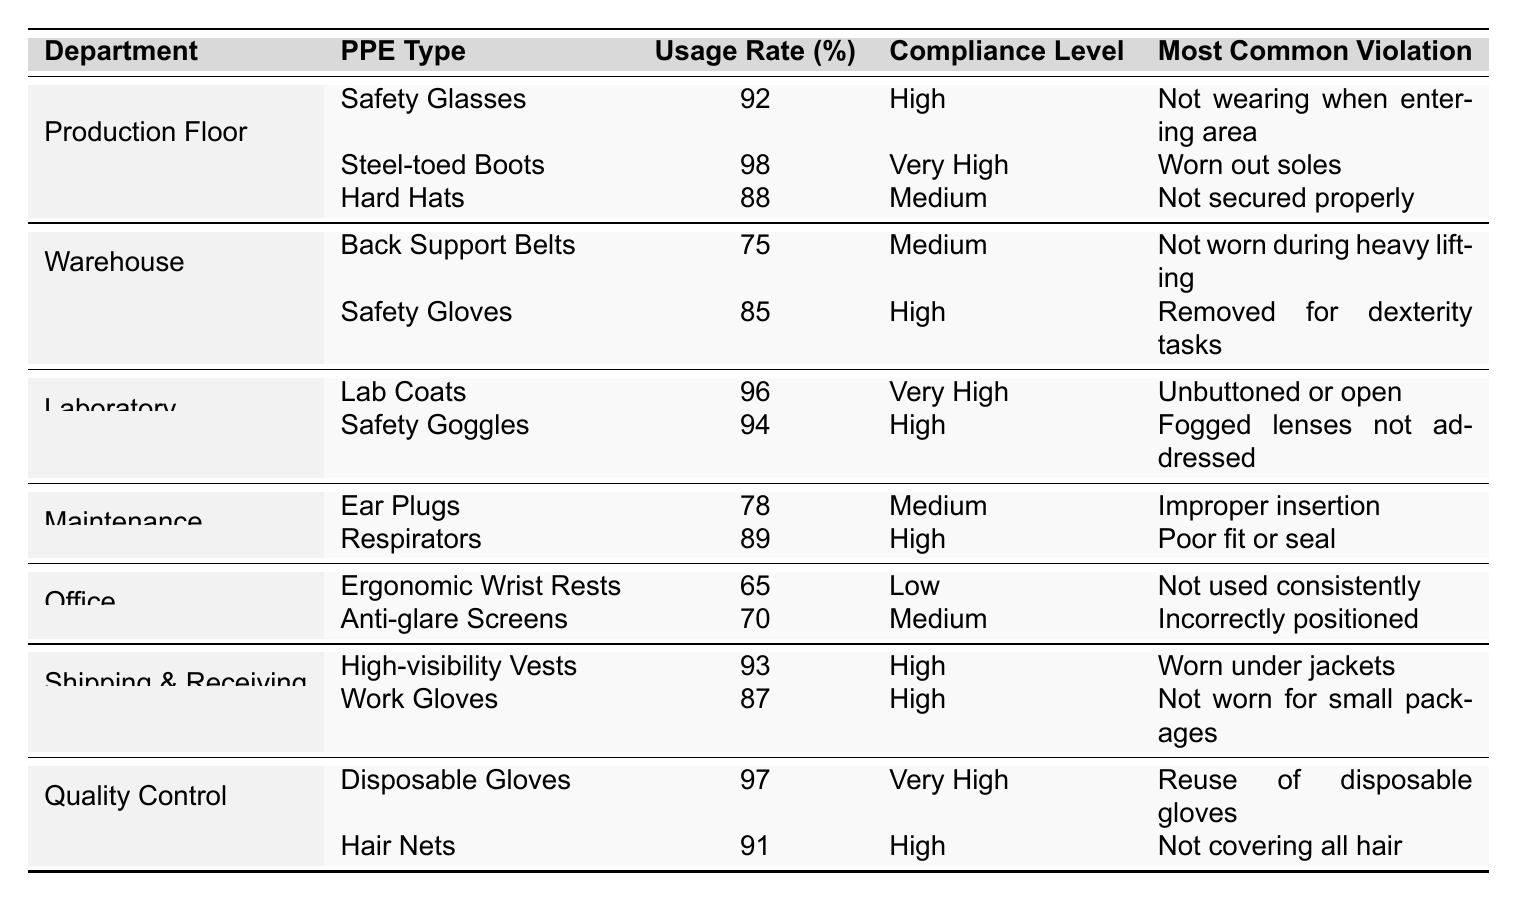What is the usage rate of safety glasses in the production floor? The table shows the usage rates for safety glasses in the production floor as 92%.
Answer: 92% Which department has the lowest PPE usage rate? Looking at the table, the office department has the lowest PPE usage rate of 65%.
Answer: 65% How many departments have a compliance level classified as "High"? The table lists the compliance levels, counting the "High" classifications, we find that there are 6 instances.
Answer: 6 What is the average usage rate of PPE in the warehouse? In the warehouse, the usage rates are 75% for back support belts and 85% for safety gloves. The average is (75 + 85) / 2 = 80%.
Answer: 80% Is the compliance level for ear plugs in maintenance classified as "Very High"? The table indicates that the compliance level for ear plugs in maintenance is "Medium", so it is not classified as "Very High".
Answer: No List the most common violation for safety goggles in the laboratory. The table states that the most common violation for safety goggles in the laboratory is "Fogged lenses not addressed".
Answer: Fogged lenses not addressed What is the difference in usage rates between steel-toed boots and work gloves? The usage rate for steel-toed boots in production is 98%, while for work gloves in shipping & receiving it's 87%. The difference is 98 - 87 = 11%.
Answer: 11% Which PPE type in the laboratory has a "Very High" compliance level? According to the table, lab coats in the laboratory have a "Very High" compliance level.
Answer: Lab Coats How many PPE types are listed for the maintenance department? The maintenance department in the table lists 2 PPE types: ear plugs and respirators.
Answer: 2 In which department is the most frequent violation related to the improper use of ergonomic wrist rests? The table indicates that in the office department, the most common violation for ergonomic wrist rests is "Not used consistently".
Answer: Office What percentage of employees on the production floor are compliant with hard hats? The compliance level for hard hats is classified as "Medium", but the actual usage rate is 88%.
Answer: 88% 